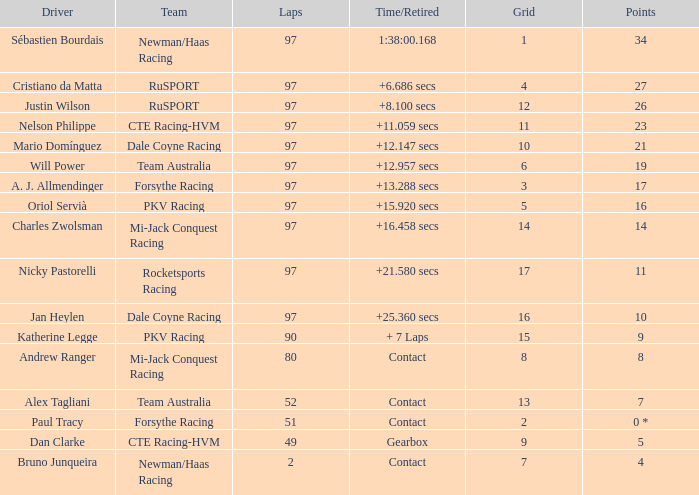Which team is jan heylen a member of for racing? Dale Coyne Racing. 